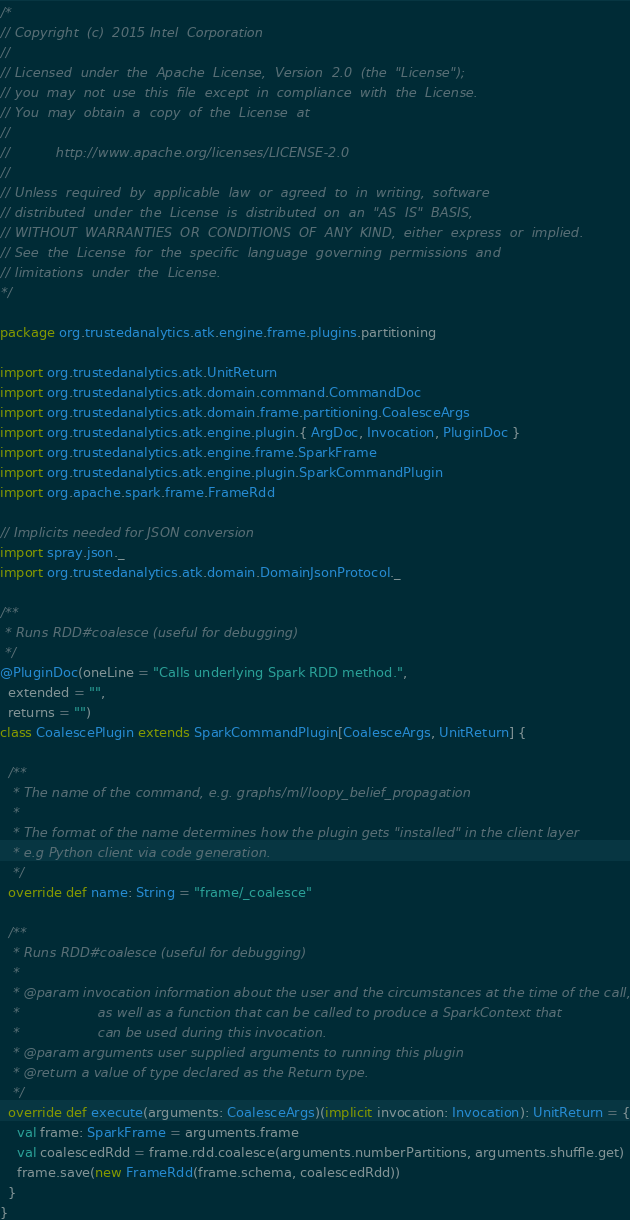Convert code to text. <code><loc_0><loc_0><loc_500><loc_500><_Scala_>/*
// Copyright (c) 2015 Intel Corporation 
//
// Licensed under the Apache License, Version 2.0 (the "License");
// you may not use this file except in compliance with the License.
// You may obtain a copy of the License at
//
//      http://www.apache.org/licenses/LICENSE-2.0
//
// Unless required by applicable law or agreed to in writing, software
// distributed under the License is distributed on an "AS IS" BASIS,
// WITHOUT WARRANTIES OR CONDITIONS OF ANY KIND, either express or implied.
// See the License for the specific language governing permissions and
// limitations under the License.
*/

package org.trustedanalytics.atk.engine.frame.plugins.partitioning

import org.trustedanalytics.atk.UnitReturn
import org.trustedanalytics.atk.domain.command.CommandDoc
import org.trustedanalytics.atk.domain.frame.partitioning.CoalesceArgs
import org.trustedanalytics.atk.engine.plugin.{ ArgDoc, Invocation, PluginDoc }
import org.trustedanalytics.atk.engine.frame.SparkFrame
import org.trustedanalytics.atk.engine.plugin.SparkCommandPlugin
import org.apache.spark.frame.FrameRdd

// Implicits needed for JSON conversion
import spray.json._
import org.trustedanalytics.atk.domain.DomainJsonProtocol._

/**
 * Runs RDD#coalesce (useful for debugging)
 */
@PluginDoc(oneLine = "Calls underlying Spark RDD method.",
  extended = "",
  returns = "")
class CoalescePlugin extends SparkCommandPlugin[CoalesceArgs, UnitReturn] {

  /**
   * The name of the command, e.g. graphs/ml/loopy_belief_propagation
   *
   * The format of the name determines how the plugin gets "installed" in the client layer
   * e.g Python client via code generation.
   */
  override def name: String = "frame/_coalesce"

  /**
   * Runs RDD#coalesce (useful for debugging)
   *
   * @param invocation information about the user and the circumstances at the time of the call,
   *                   as well as a function that can be called to produce a SparkContext that
   *                   can be used during this invocation.
   * @param arguments user supplied arguments to running this plugin
   * @return a value of type declared as the Return type.
   */
  override def execute(arguments: CoalesceArgs)(implicit invocation: Invocation): UnitReturn = {
    val frame: SparkFrame = arguments.frame
    val coalescedRdd = frame.rdd.coalesce(arguments.numberPartitions, arguments.shuffle.get)
    frame.save(new FrameRdd(frame.schema, coalescedRdd))
  }
}
</code> 